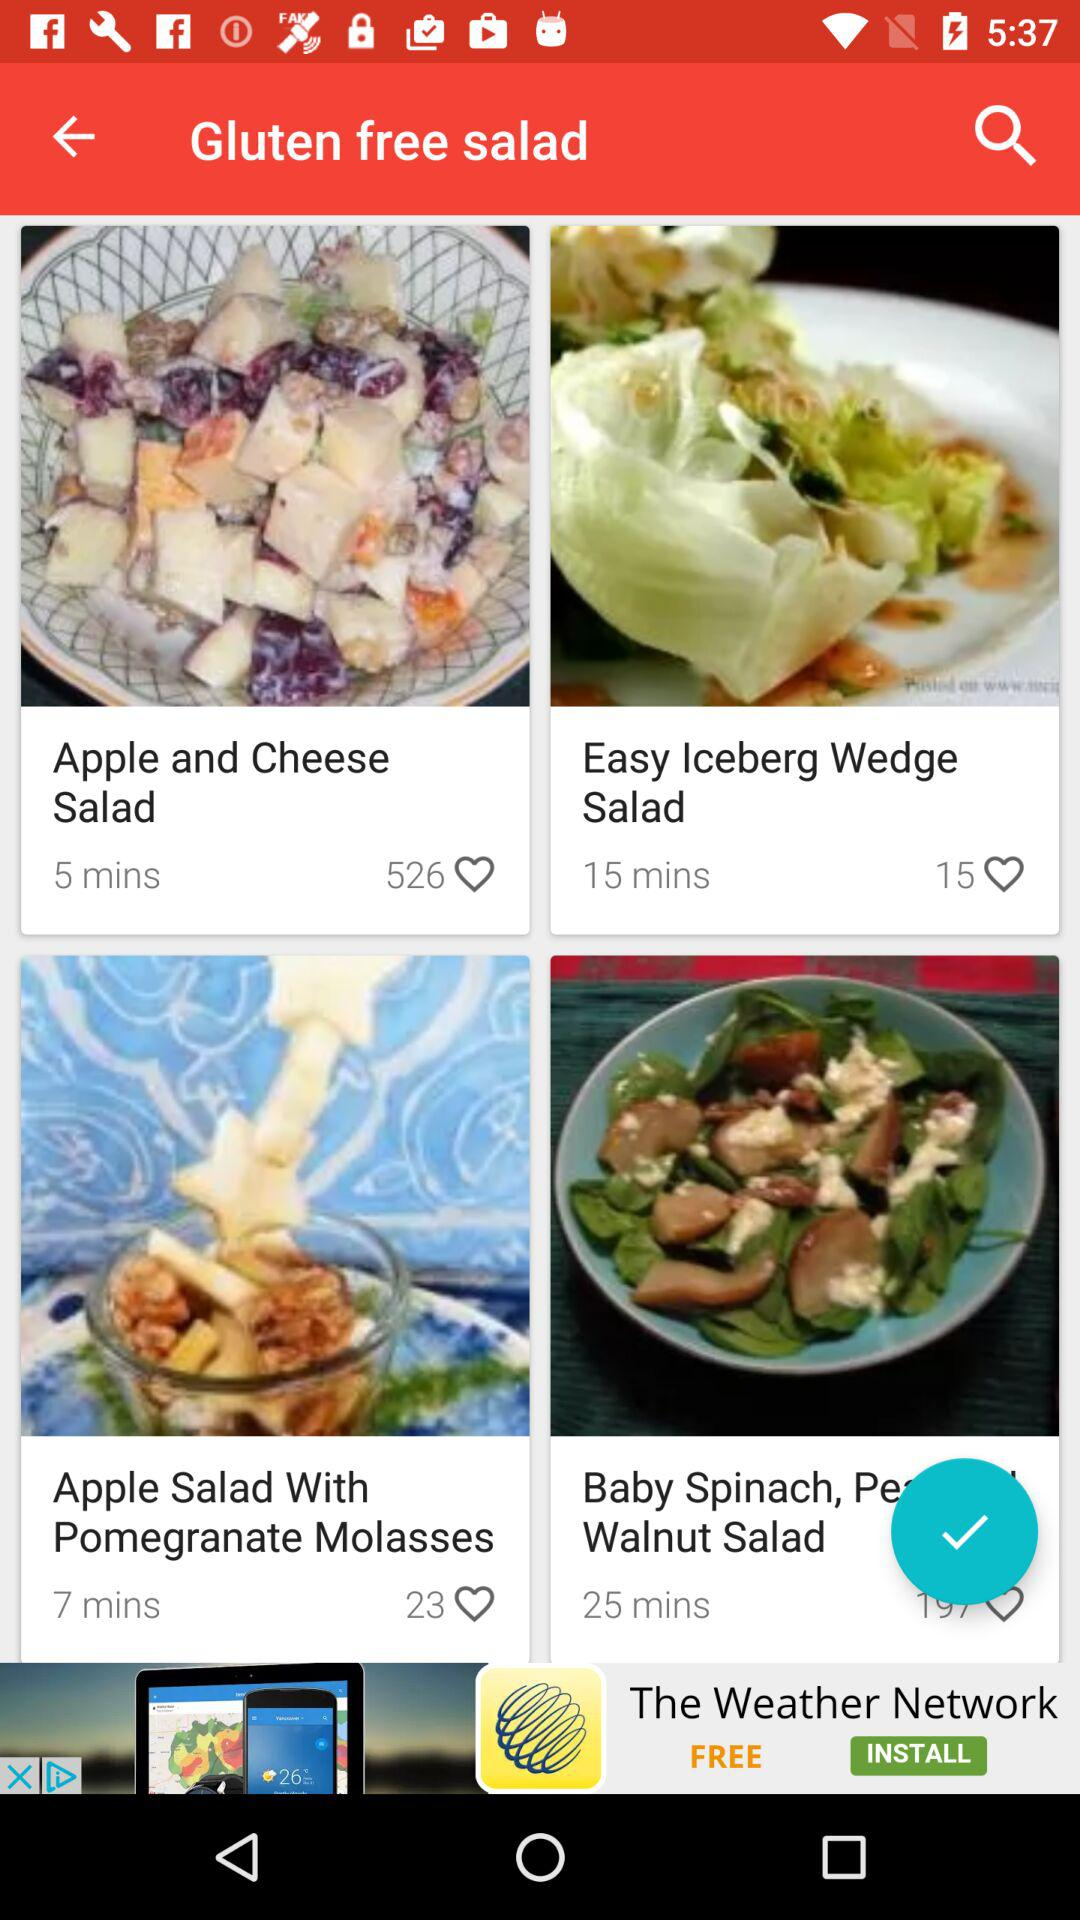In how many minutes will the Apple and Cheese Salad be prepared? It will be prepared in 5 minutes. 